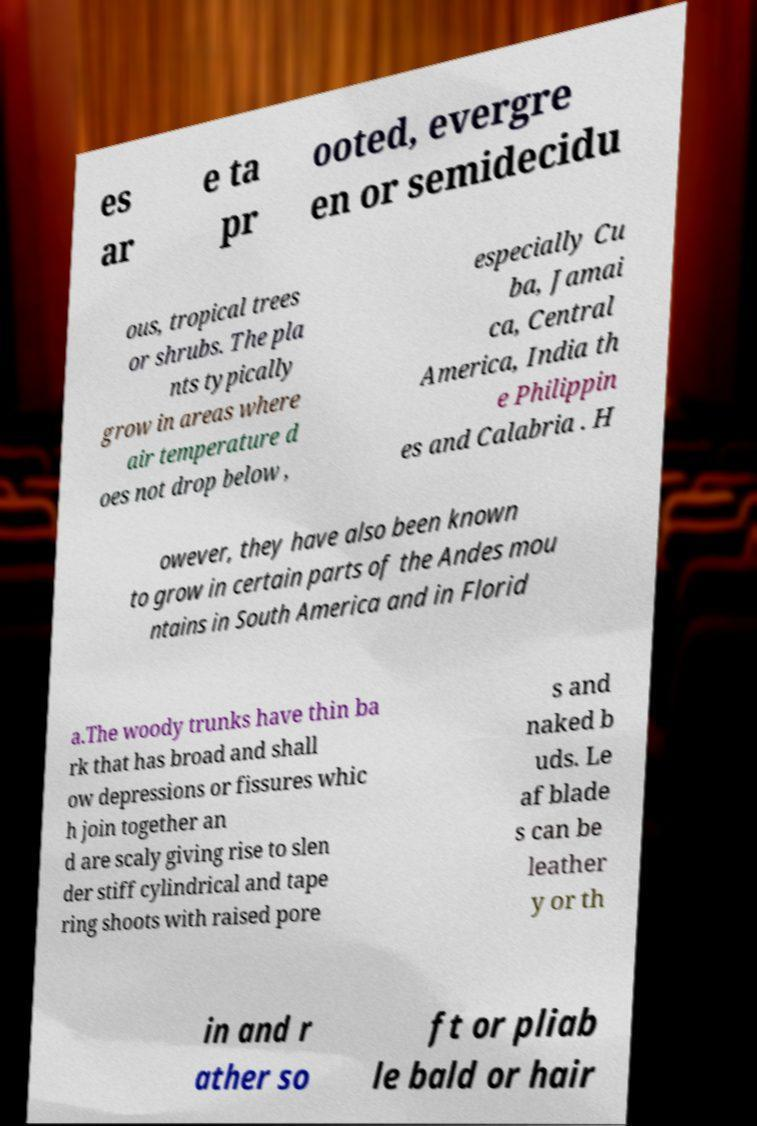Can you read and provide the text displayed in the image?This photo seems to have some interesting text. Can you extract and type it out for me? es ar e ta pr ooted, evergre en or semidecidu ous, tropical trees or shrubs. The pla nts typically grow in areas where air temperature d oes not drop below , especially Cu ba, Jamai ca, Central America, India th e Philippin es and Calabria . H owever, they have also been known to grow in certain parts of the Andes mou ntains in South America and in Florid a.The woody trunks have thin ba rk that has broad and shall ow depressions or fissures whic h join together an d are scaly giving rise to slen der stiff cylindrical and tape ring shoots with raised pore s and naked b uds. Le af blade s can be leather y or th in and r ather so ft or pliab le bald or hair 